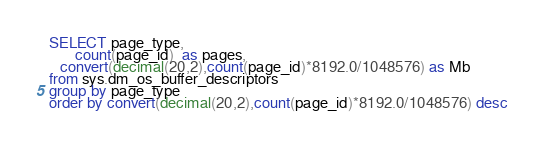Convert code to text. <code><loc_0><loc_0><loc_500><loc_500><_SQL_>SELECT page_type,
       count(page_id)  as pages,
   convert(decimal(20,2),count(page_id)*8192.0/1048576) as Mb
from sys.dm_os_buffer_descriptors
group by page_type
order by convert(decimal(20,2),count(page_id)*8192.0/1048576) desc</code> 